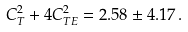<formula> <loc_0><loc_0><loc_500><loc_500>C _ { T } ^ { 2 } + 4 C _ { T E } ^ { 2 } = 2 . 5 8 \pm 4 . 1 7 \, .</formula> 